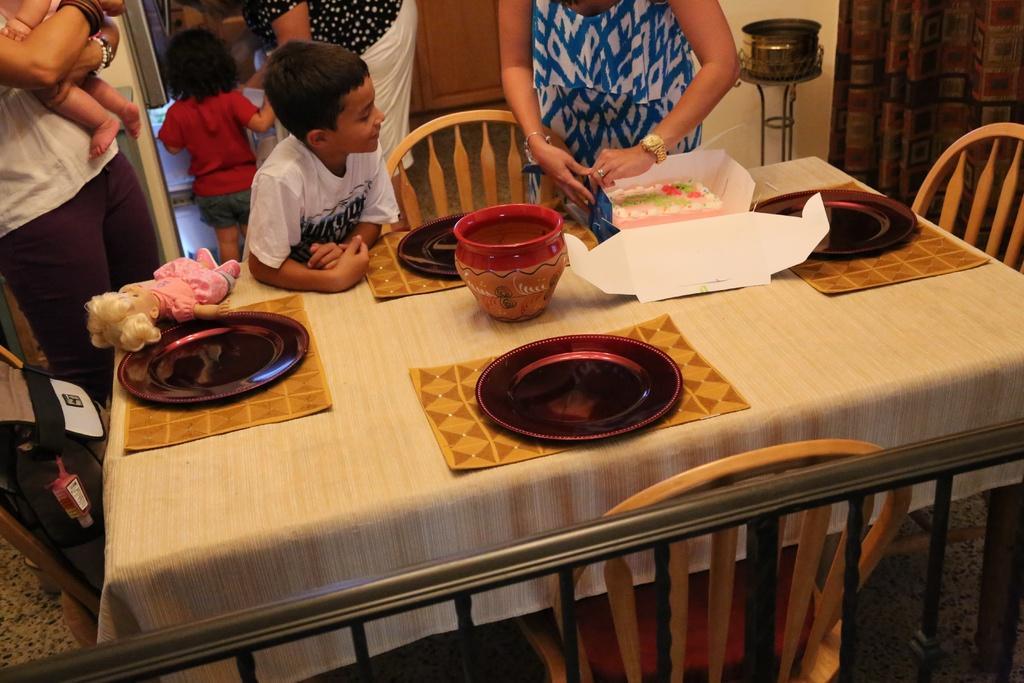Please provide a concise description of this image. in this image i can see a table and plates on the table. there is a pink color cake on the table. there are many people standing behind. there is a pink color doll placed on the table. and a bag at the left side 